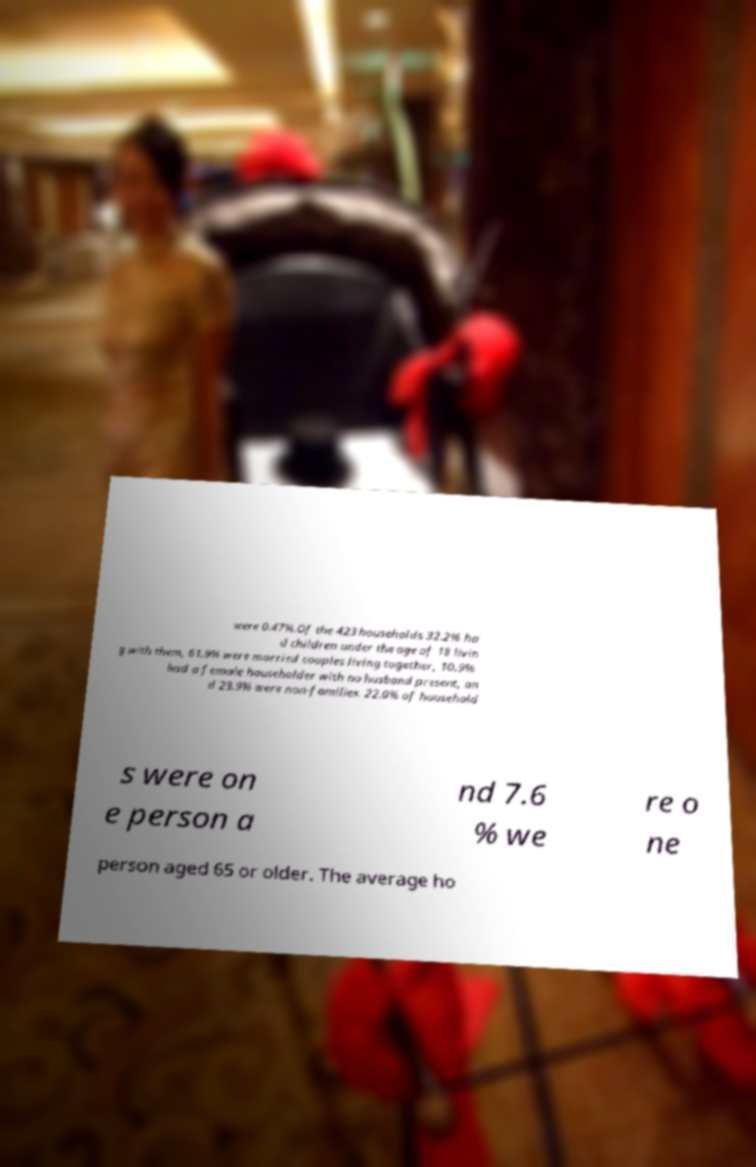Could you assist in decoding the text presented in this image and type it out clearly? were 0.47%.Of the 423 households 32.2% ha d children under the age of 18 livin g with them, 61.9% were married couples living together, 10.9% had a female householder with no husband present, an d 23.9% were non-families. 22.0% of household s were on e person a nd 7.6 % we re o ne person aged 65 or older. The average ho 